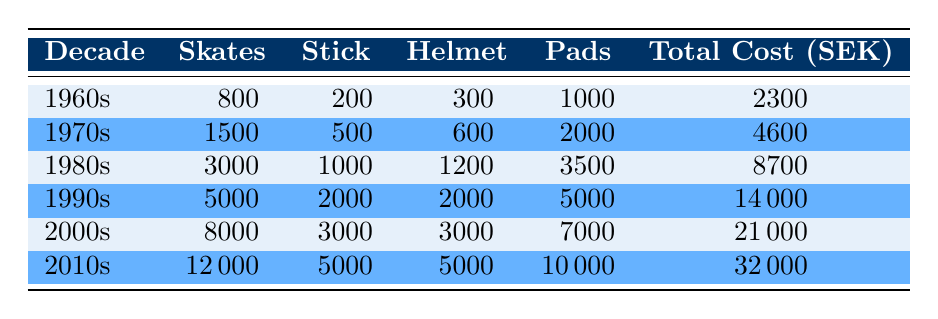What was the total cost of equipment in the 1980s? The total cost of equipment for the 1980s is listed in the table under the "Total Cost (SEK)" column for that decade, which shows 8700 SEK.
Answer: 8700 How much did skates cost in the 2000s? The cost of skates for the 2000s can be found in the table in the "Skates" column for that decade, which is 8000 SEK.
Answer: 8000 What is the difference in total cost between the 1970s and the 1990s? The total cost for the 1970s is 4600 SEK and for the 1990s, it is 14000 SEK. To find the difference, subtract 4600 from 14000, which gives 14000 - 4600 = 9400 SEK.
Answer: 9400 Is the cost of protective pads in the 2010s higher than in the 1960s? The protective pads cost in the 2010s is 10000 SEK, while in the 1960s, they cost 1000 SEK. Since 10000 is greater than 1000, the statement is true.
Answer: Yes In which decade did skates have the highest cost? To find when skates had the highest cost, we can compare the values in the "Skates" column across all decades. The highest value listed is 12000 SEK in the 2010s.
Answer: 2010s What is the average cost of sticks from the 1960s to the 2000s? For the average cost of sticks, we add the costs from each decade: 200 (1960s) + 500 (1970s) + 1000 (1980s) + 2000 (1990s) + 3000 (2000s) = 5700 SEK. Then we divide by the number of decades (5): 5700 / 5 = 1140 SEK.
Answer: 1140 True or False: The total cost of equipment in the 1970s is less than in the 1980s. The total cost for the 1970s is 4600 SEK and for the 1980s is 8700 SEK. Since 4600 is less than 8700, the statement is true.
Answer: True What was the total cost of equipment in the 1960s compared to the 2000s? The total cost for the 1960s is 2300 SEK while for the 2000s it is 21000 SEK. Comparing these, 21000 is much greater than 2300. Thus, the 2000s had a significantly higher total cost.
Answer: 21000 is higher than 2300 